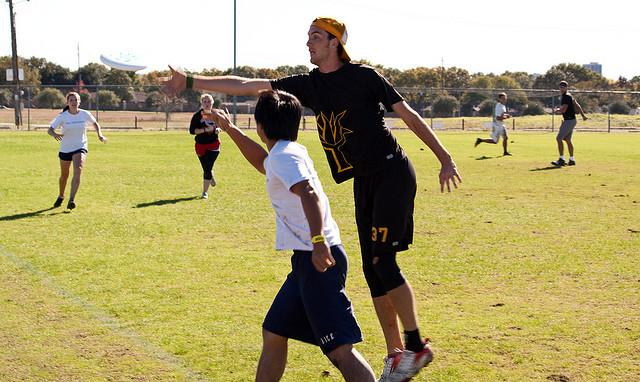What sport are the people playing?

Choices:
A) ultimate frisbee
B) baseball
C) football
D) field hockey ultimate frisbee 